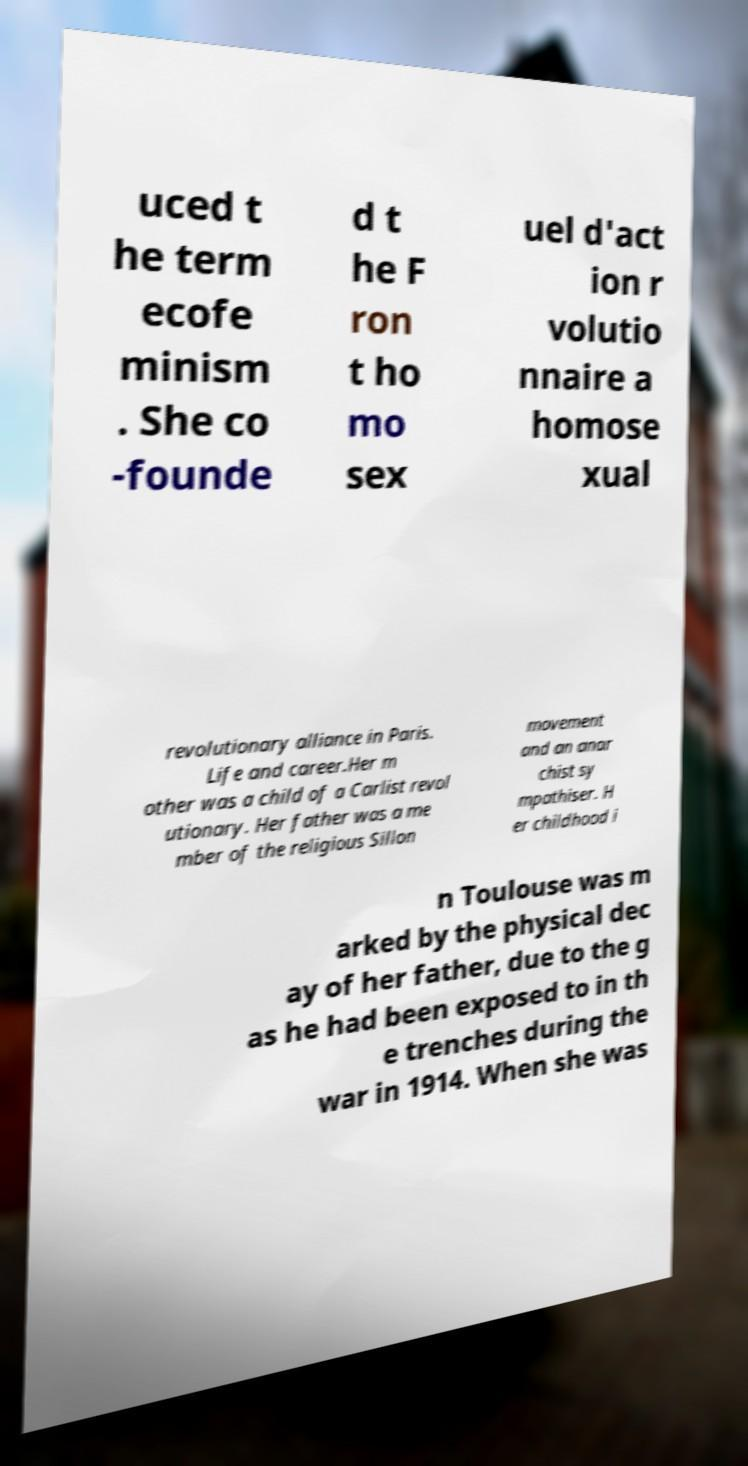There's text embedded in this image that I need extracted. Can you transcribe it verbatim? uced t he term ecofe minism . She co -founde d t he F ron t ho mo sex uel d'act ion r volutio nnaire a homose xual revolutionary alliance in Paris. Life and career.Her m other was a child of a Carlist revol utionary. Her father was a me mber of the religious Sillon movement and an anar chist sy mpathiser. H er childhood i n Toulouse was m arked by the physical dec ay of her father, due to the g as he had been exposed to in th e trenches during the war in 1914. When she was 